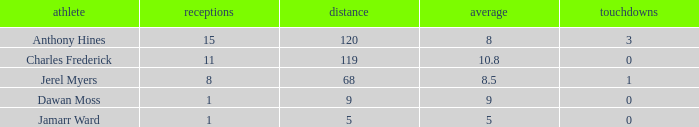What is the highest number of TDs when the Avg is larger than 8.5 and the Rec is less than 1? None. 